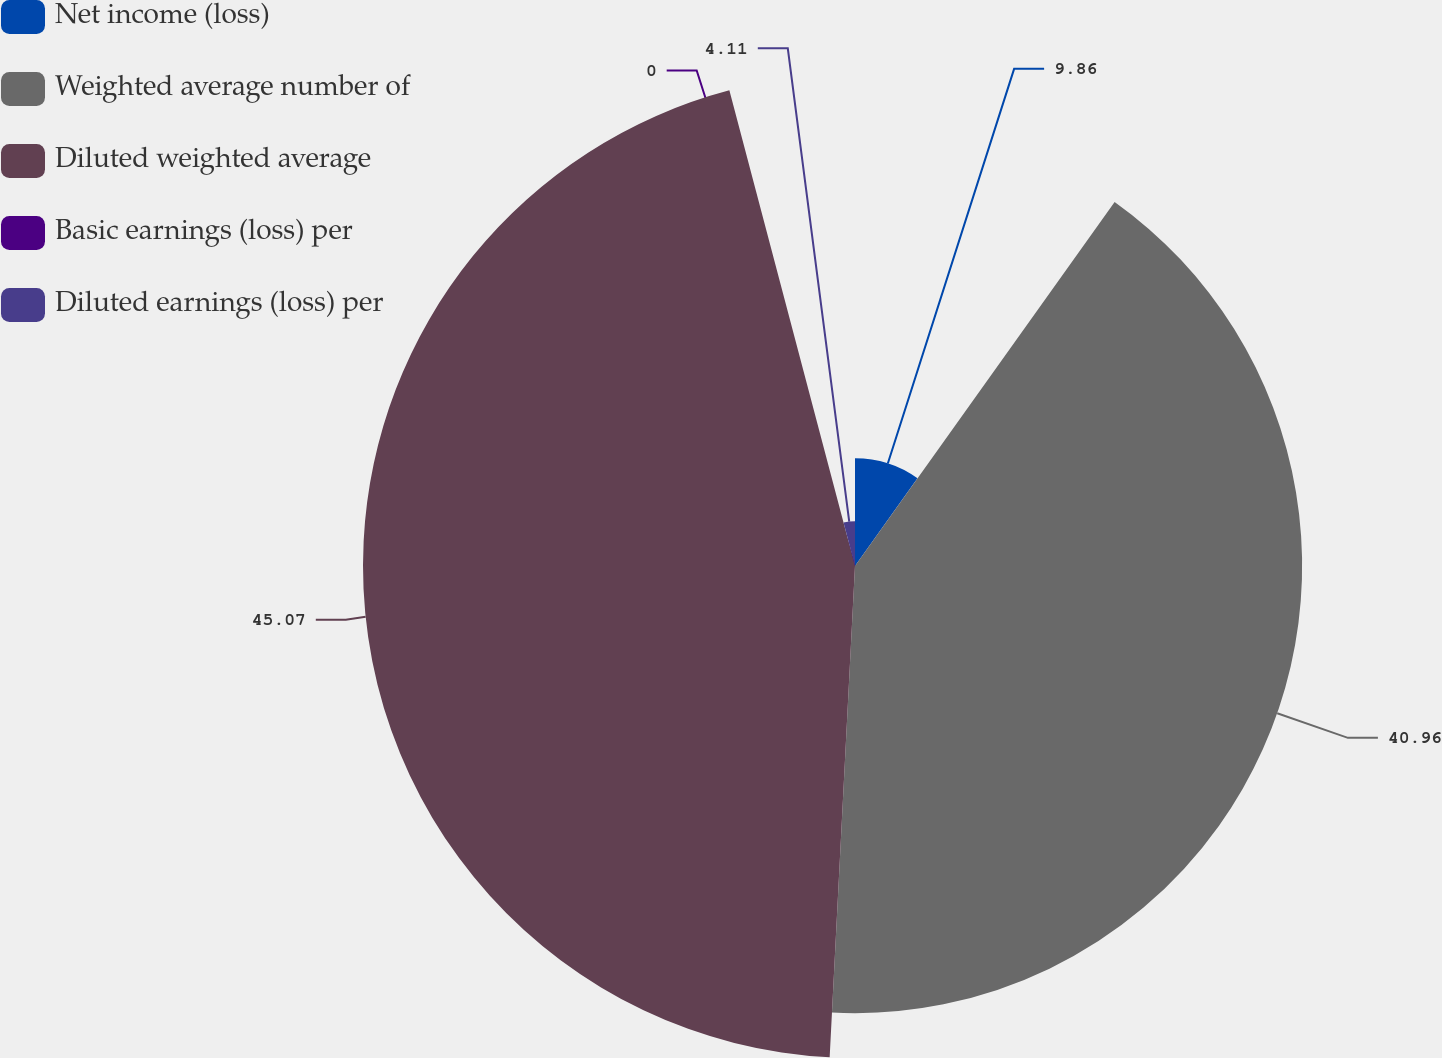<chart> <loc_0><loc_0><loc_500><loc_500><pie_chart><fcel>Net income (loss)<fcel>Weighted average number of<fcel>Diluted weighted average<fcel>Basic earnings (loss) per<fcel>Diluted earnings (loss) per<nl><fcel>9.86%<fcel>40.96%<fcel>45.07%<fcel>0.0%<fcel>4.11%<nl></chart> 